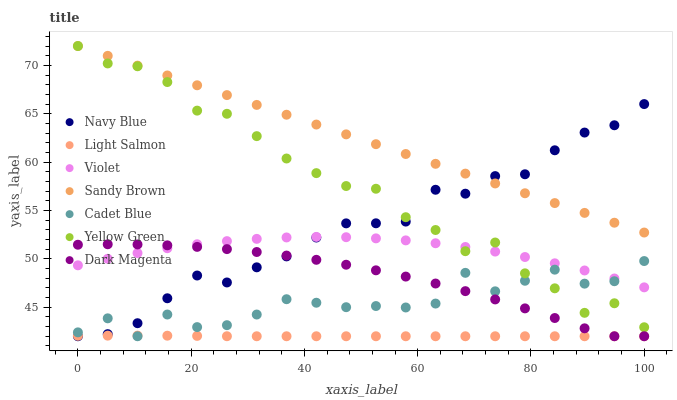Does Light Salmon have the minimum area under the curve?
Answer yes or no. Yes. Does Sandy Brown have the maximum area under the curve?
Answer yes or no. Yes. Does Cadet Blue have the minimum area under the curve?
Answer yes or no. No. Does Cadet Blue have the maximum area under the curve?
Answer yes or no. No. Is Sandy Brown the smoothest?
Answer yes or no. Yes. Is Cadet Blue the roughest?
Answer yes or no. Yes. Is Yellow Green the smoothest?
Answer yes or no. No. Is Yellow Green the roughest?
Answer yes or no. No. Does Light Salmon have the lowest value?
Answer yes or no. Yes. Does Yellow Green have the lowest value?
Answer yes or no. No. Does Sandy Brown have the highest value?
Answer yes or no. Yes. Does Cadet Blue have the highest value?
Answer yes or no. No. Is Light Salmon less than Yellow Green?
Answer yes or no. Yes. Is Violet greater than Light Salmon?
Answer yes or no. Yes. Does Navy Blue intersect Light Salmon?
Answer yes or no. Yes. Is Navy Blue less than Light Salmon?
Answer yes or no. No. Is Navy Blue greater than Light Salmon?
Answer yes or no. No. Does Light Salmon intersect Yellow Green?
Answer yes or no. No. 